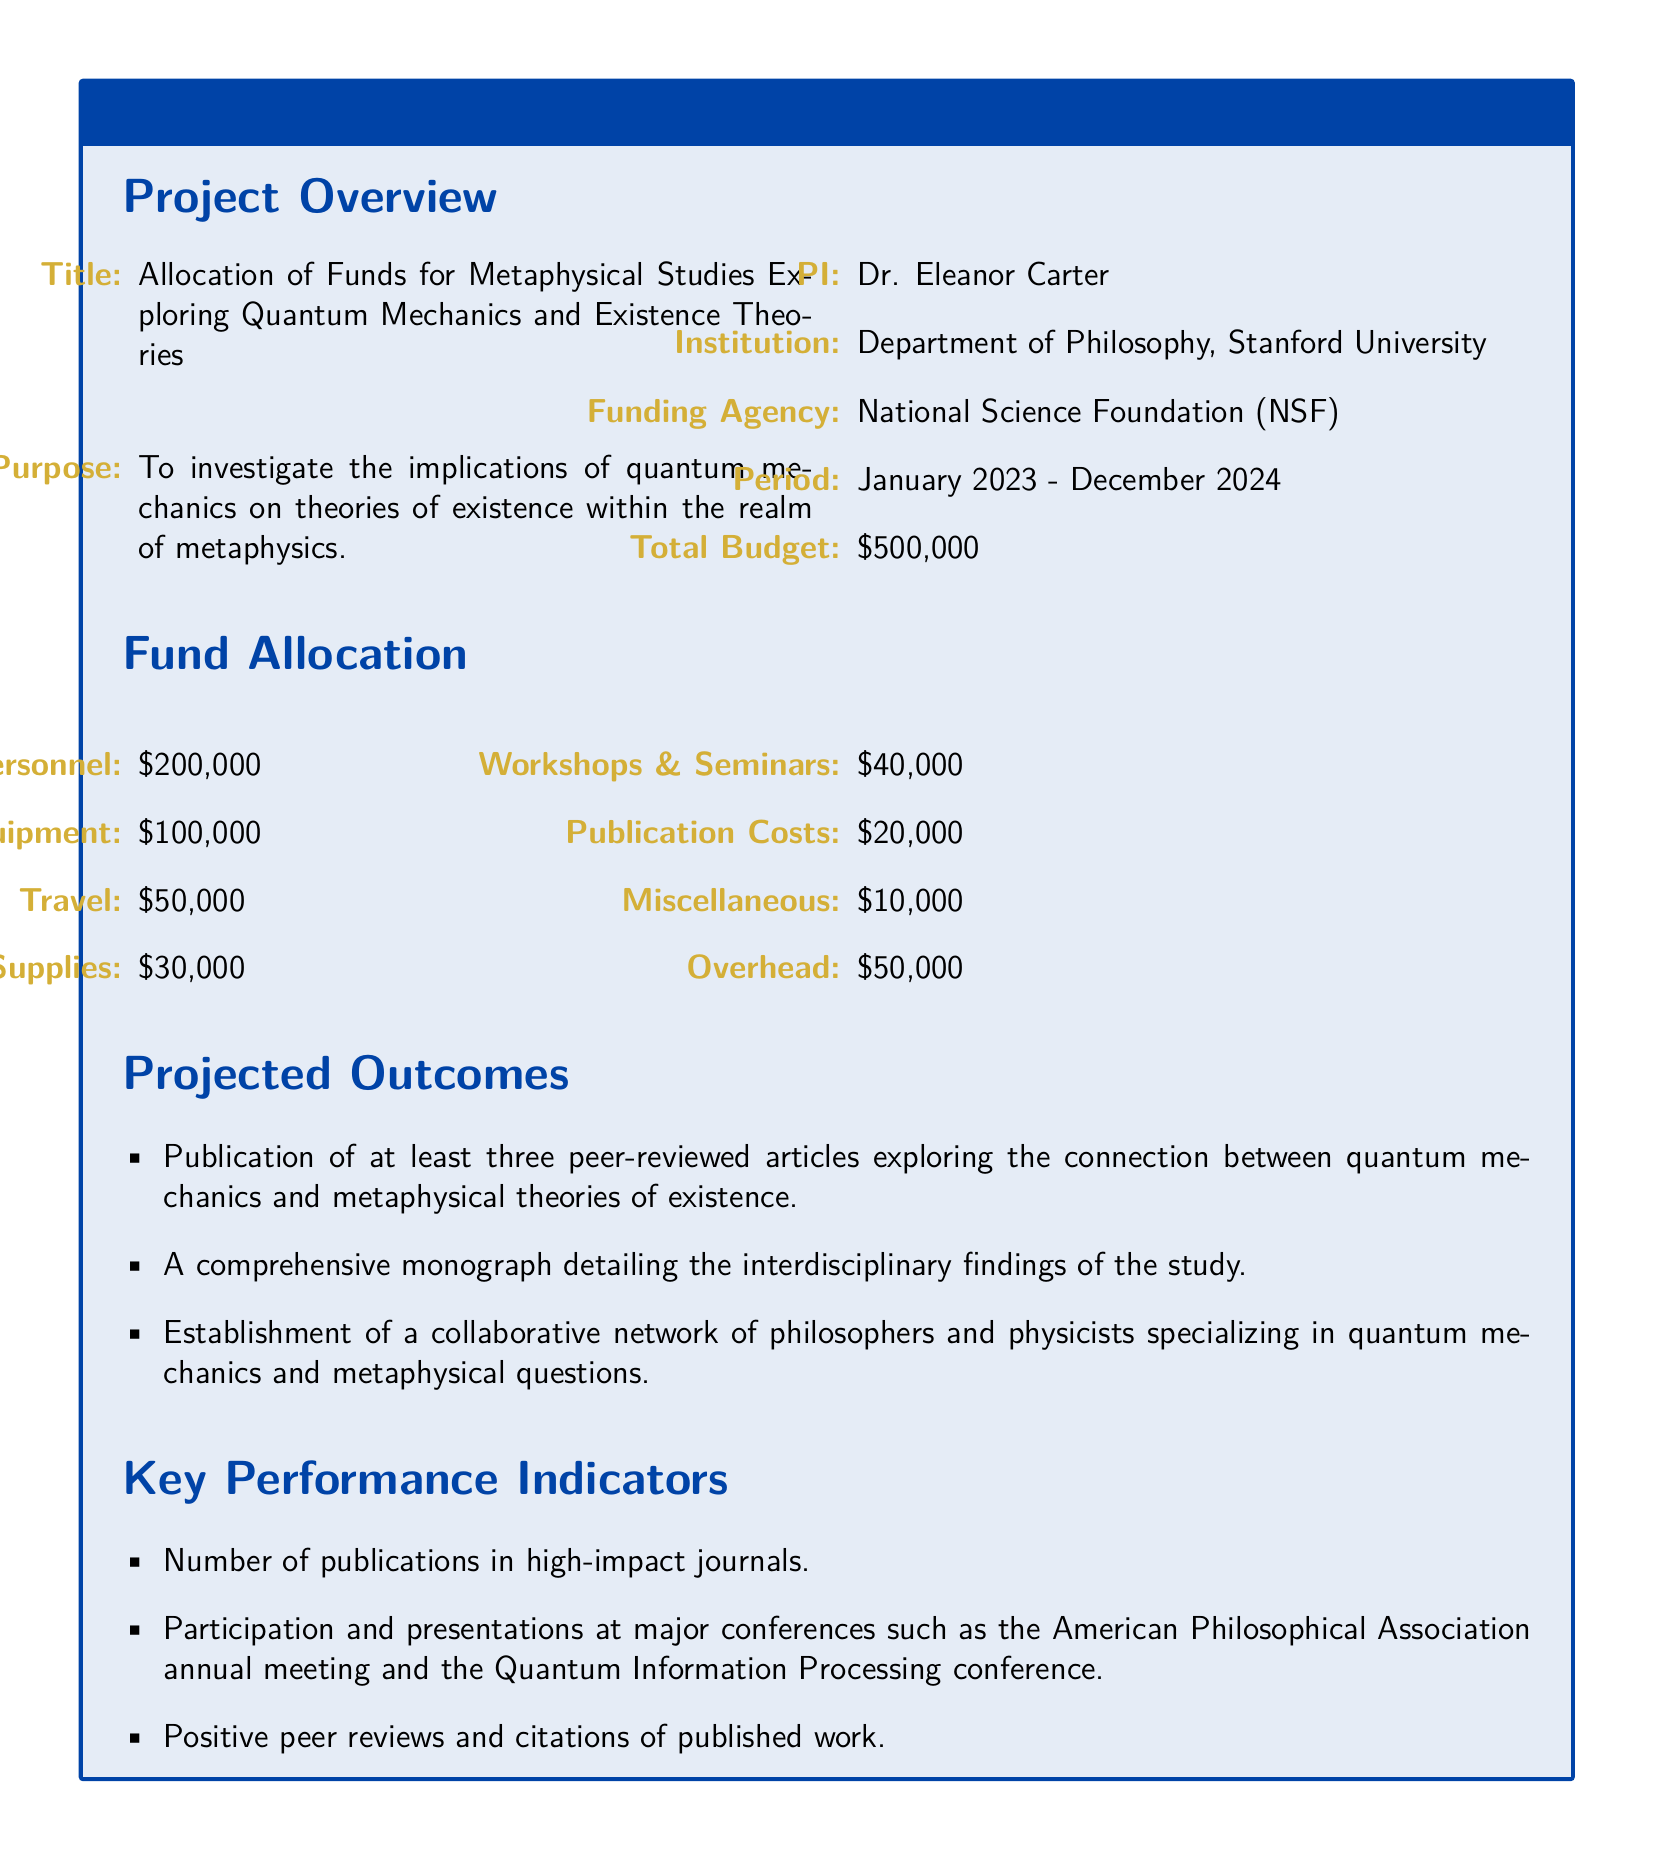What is the title of the project? The title of the project is listed under "Project Overview" in the document.
Answer: Allocation of Funds for Metaphysical Studies Exploring Quantum Mechanics and Existence Theories Who is the Principal Investigator (PI) of the project? The PI of the project is mentioned in the "Project Overview" section.
Answer: Dr. Eleanor Carter What is the total budget allocated for the project? The total budget is stated in the "Project Overview" section.
Answer: $500,000 How much is allocated for personnel in the fund allocation? The allocation for personnel is specified in the "Fund Allocation" section of the document.
Answer: $200,000 What is the purpose of the project? The purpose is described in the "Project Overview" and encapsulates the main aim of the research.
Answer: To investigate the implications of quantum mechanics on theories of existence within the realm of metaphysics What is one of the projected outcomes of the research? Projected outcomes are listed in the "Projected Outcomes" section, outlining expected achievements.
Answer: Publication of at least three peer-reviewed articles exploring the connection between quantum mechanics and metaphysical theories of existence How much funding is allocated for workshops and seminars? The amount allocated for workshops and seminars is detailed in the "Fund Allocation" section.
Answer: $40,000 What is a key performance indicator mentioned in the document? Key performance indicators are specified, which measure the success of the project.
Answer: Number of publications in high-impact journals 